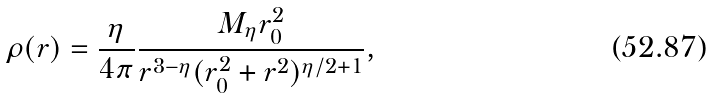Convert formula to latex. <formula><loc_0><loc_0><loc_500><loc_500>\rho ( r ) = \frac { \eta } { 4 \pi } \frac { M _ { \eta } r _ { 0 } ^ { 2 } } { r ^ { 3 - \eta } ( r _ { 0 } ^ { 2 } + r ^ { 2 } ) ^ { \eta / 2 + 1 } } ,</formula> 